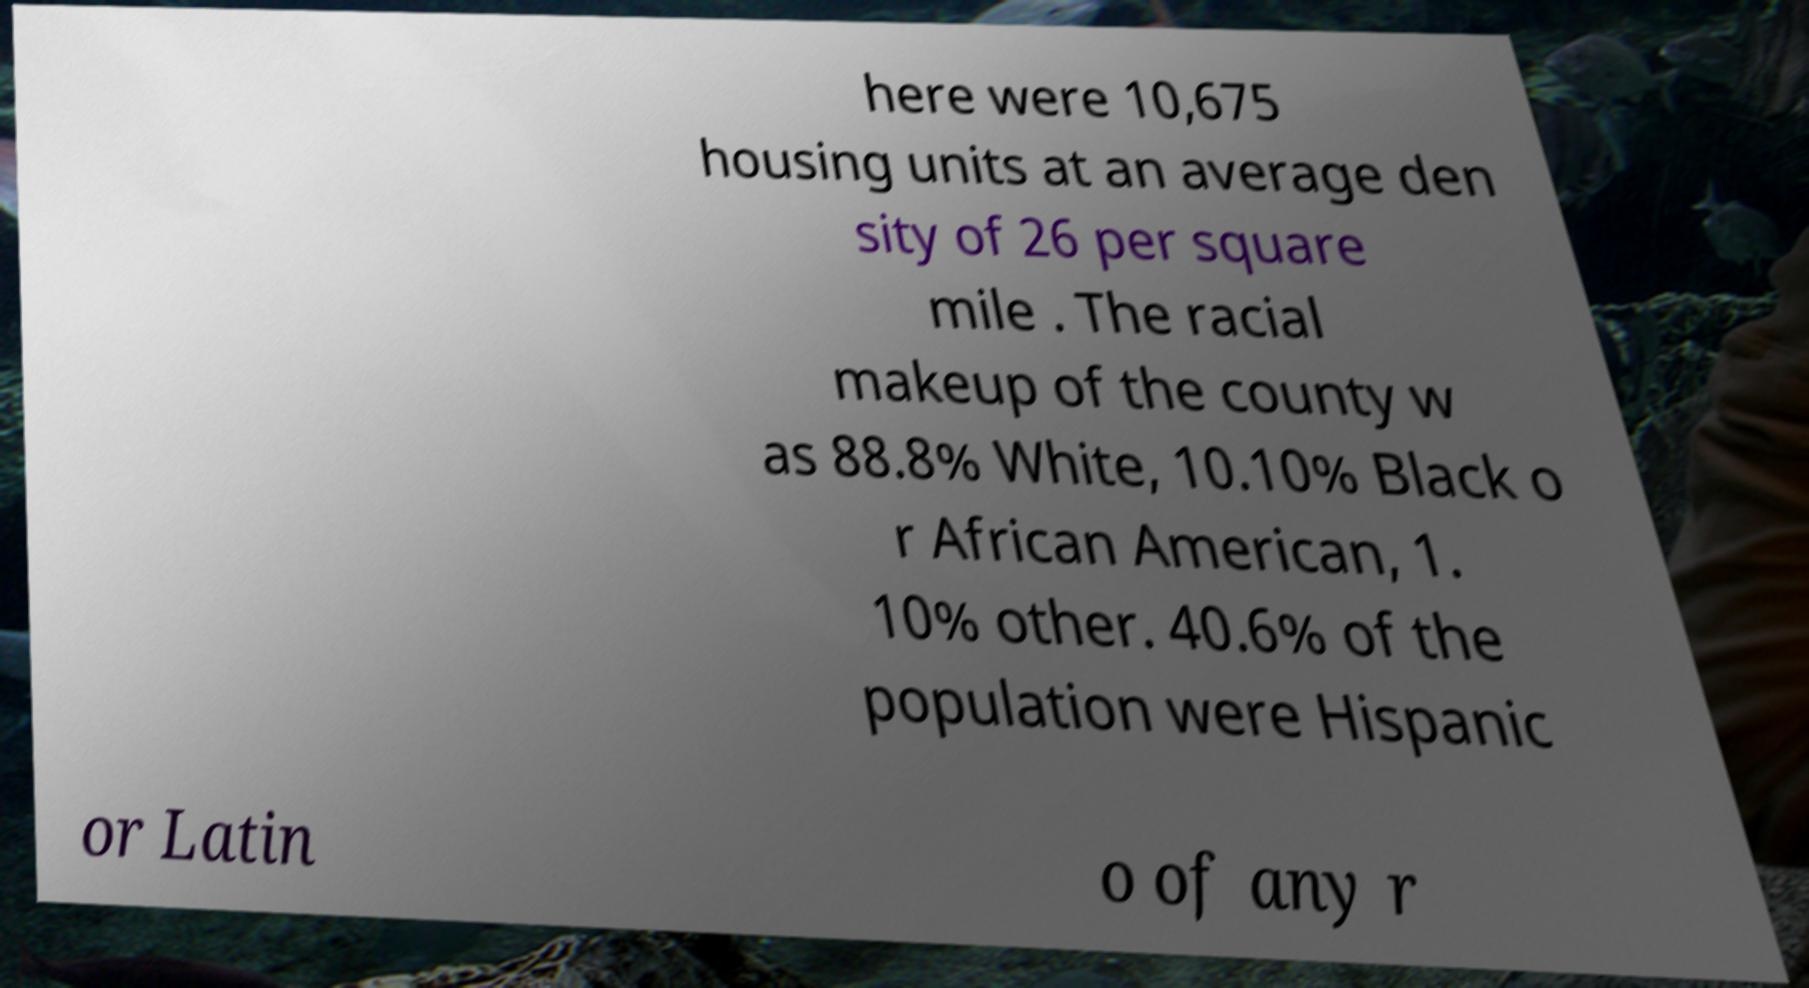Could you assist in decoding the text presented in this image and type it out clearly? here were 10,675 housing units at an average den sity of 26 per square mile . The racial makeup of the county w as 88.8% White, 10.10% Black o r African American, 1. 10% other. 40.6% of the population were Hispanic or Latin o of any r 